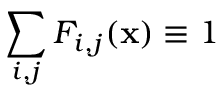<formula> <loc_0><loc_0><loc_500><loc_500>\sum _ { i , j } F _ { i , j } ( x ) \equiv 1</formula> 